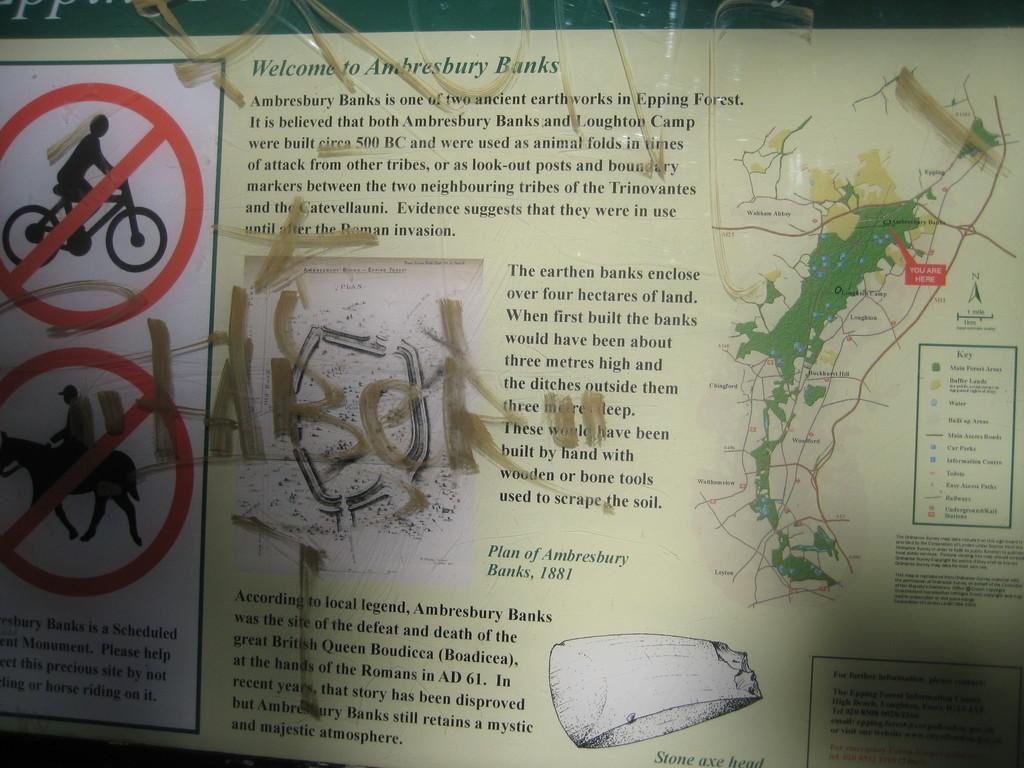<image>
Describe the image concisely. A graffitied sign welcoming visitors to Ambresbury Banks. 